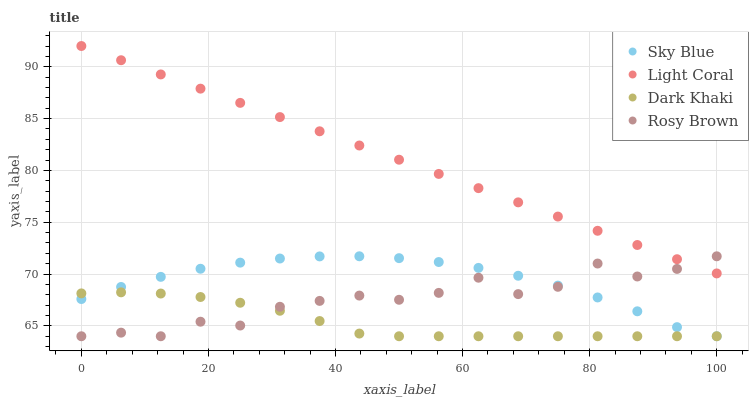Does Dark Khaki have the minimum area under the curve?
Answer yes or no. Yes. Does Light Coral have the maximum area under the curve?
Answer yes or no. Yes. Does Sky Blue have the minimum area under the curve?
Answer yes or no. No. Does Sky Blue have the maximum area under the curve?
Answer yes or no. No. Is Light Coral the smoothest?
Answer yes or no. Yes. Is Rosy Brown the roughest?
Answer yes or no. Yes. Is Sky Blue the smoothest?
Answer yes or no. No. Is Sky Blue the roughest?
Answer yes or no. No. Does Sky Blue have the lowest value?
Answer yes or no. Yes. Does Light Coral have the highest value?
Answer yes or no. Yes. Does Sky Blue have the highest value?
Answer yes or no. No. Is Sky Blue less than Light Coral?
Answer yes or no. Yes. Is Light Coral greater than Dark Khaki?
Answer yes or no. Yes. Does Dark Khaki intersect Rosy Brown?
Answer yes or no. Yes. Is Dark Khaki less than Rosy Brown?
Answer yes or no. No. Is Dark Khaki greater than Rosy Brown?
Answer yes or no. No. Does Sky Blue intersect Light Coral?
Answer yes or no. No. 